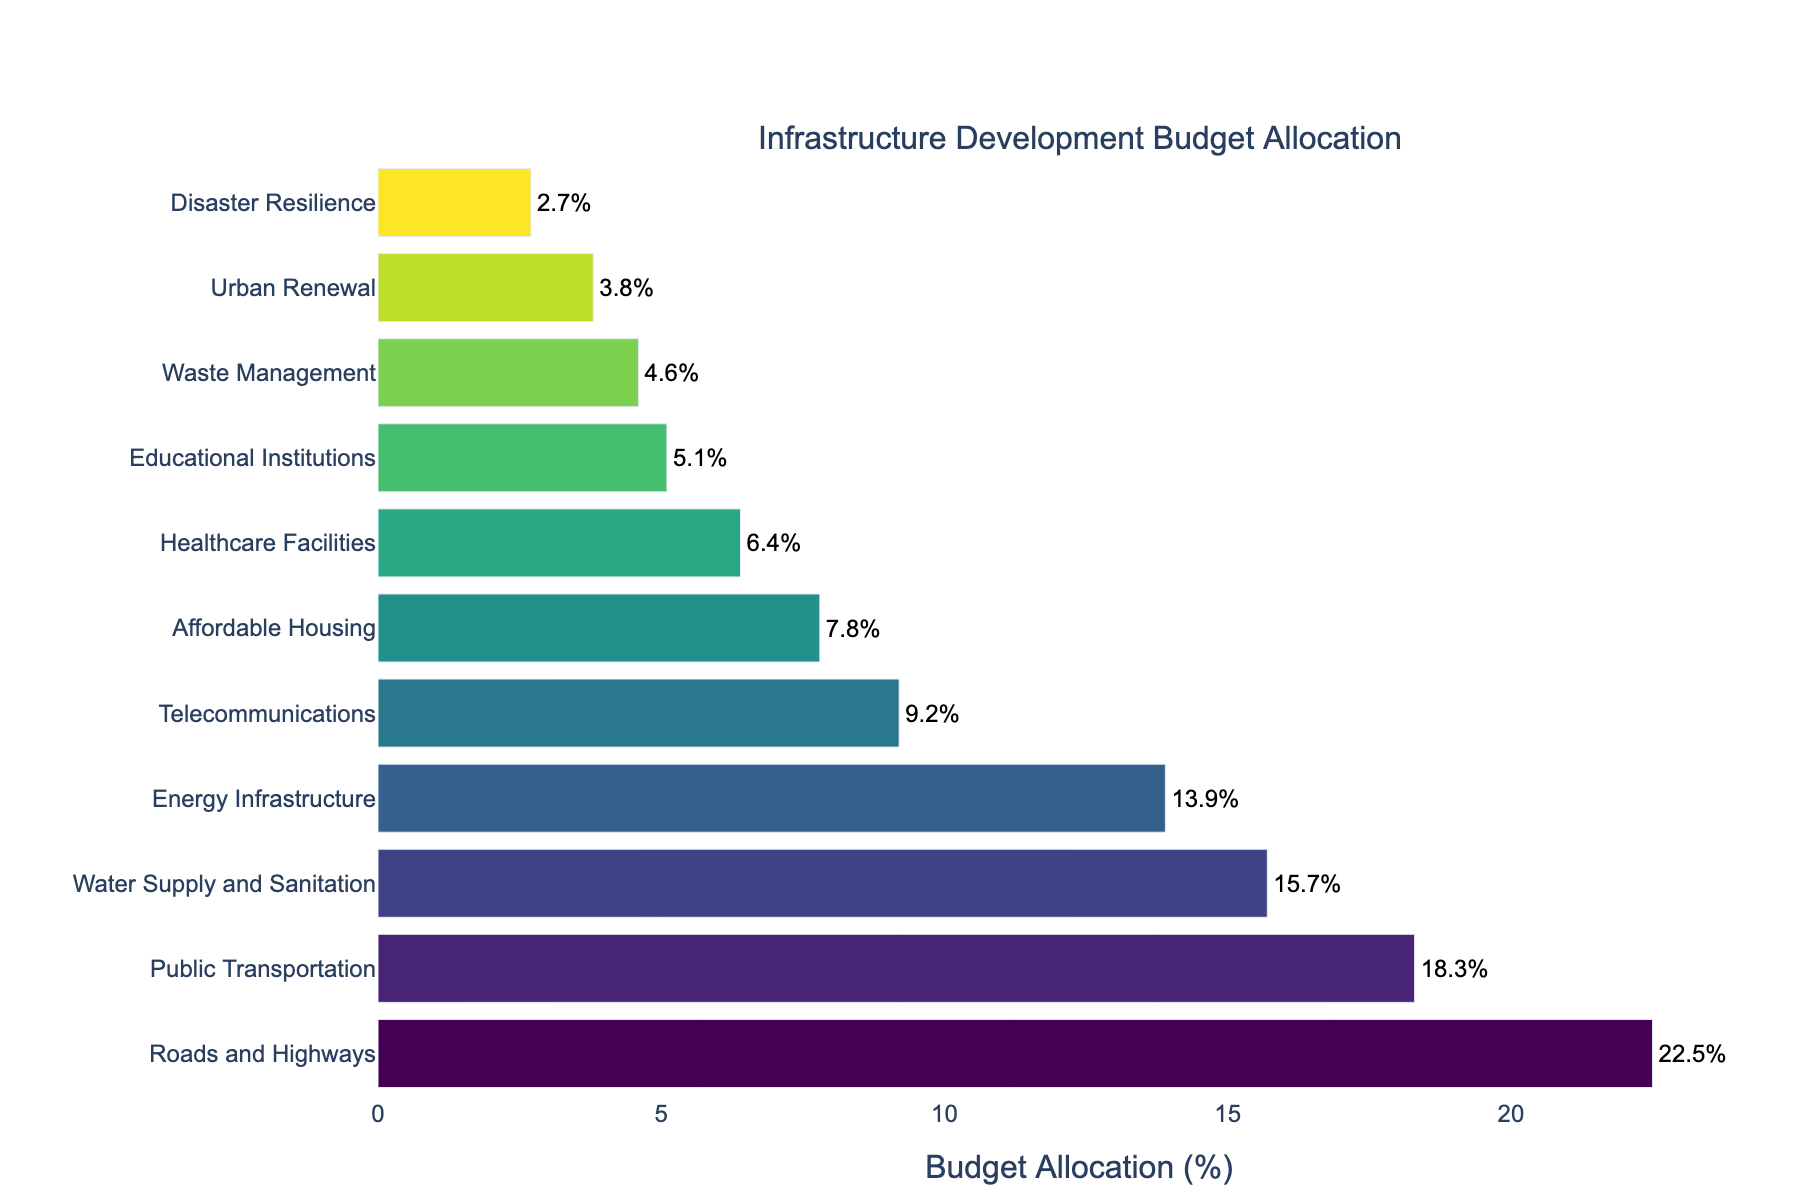What percentage of the budget is allocated to Public Transportation? Look at the bar length corresponding to Public Transportation, and the text label indicates the exact percentage.
Answer: 18.3% Which project has the highest percentage of the budget allocation? Identify the bar that is the longest and visually placed highest on the y-axis.
Answer: Roads and Highways How much more percentage is allocated to Roads and Highways compared to Telecommunications? Subtract the percentage of Telecommunications from the percentage of Roads and Highways.
Answer: 22.5% - 9.2% = 13.3% What is the combined budget allocation percentage for Healthcare Facilities and Educational Institutions? Add the percentages of Healthcare Facilities and Educational Institutions.
Answer: 6.4% + 5.1% = 11.5% Which project has the least budget allocation? Find the bar that is the shortest and visually placed lowest on the y-axis.
Answer: Disaster Resilience Is the budget allocation for Water Supply and Sanitation greater than for Energy Infrastructure? Compare the lengths of the bars for Water Supply and Sanitation and Energy Infrastructure.
Answer: Yes What is the average budget allocation percentage for the top three projects? Identify the top three projects, sum their percentages, then divide by 3.
Answer: (22.5% + 18.3% + 15.7%) / 3 = 18.83% How many projects have a budget allocation percentage less than 10%? Count the bars that correspond to percentages less than 10%.
Answer: 6 